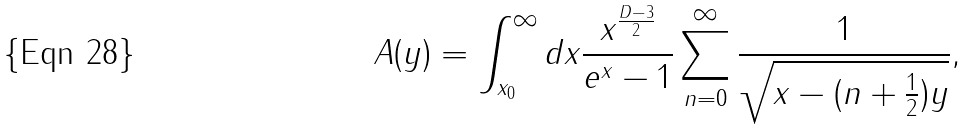<formula> <loc_0><loc_0><loc_500><loc_500>A ( y ) = \int _ { x _ { 0 } } ^ { \infty } d x \frac { x ^ { \frac { D - 3 } { 2 } } } { e ^ { x } - 1 } \sum _ { n = 0 } ^ { \infty } \frac { 1 } { \sqrt { x - ( n + \frac { 1 } { 2 } ) y } } ,</formula> 